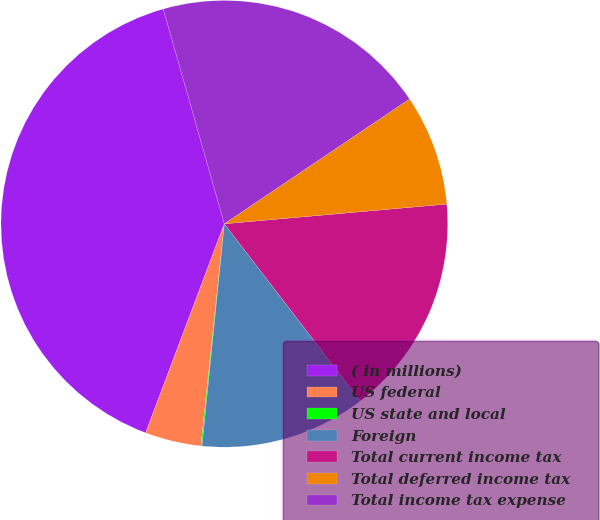<chart> <loc_0><loc_0><loc_500><loc_500><pie_chart><fcel>( in millions)<fcel>US federal<fcel>US state and local<fcel>Foreign<fcel>Total current income tax<fcel>Total deferred income tax<fcel>Total income tax expense<nl><fcel>39.86%<fcel>4.06%<fcel>0.08%<fcel>12.01%<fcel>15.99%<fcel>8.03%<fcel>19.97%<nl></chart> 